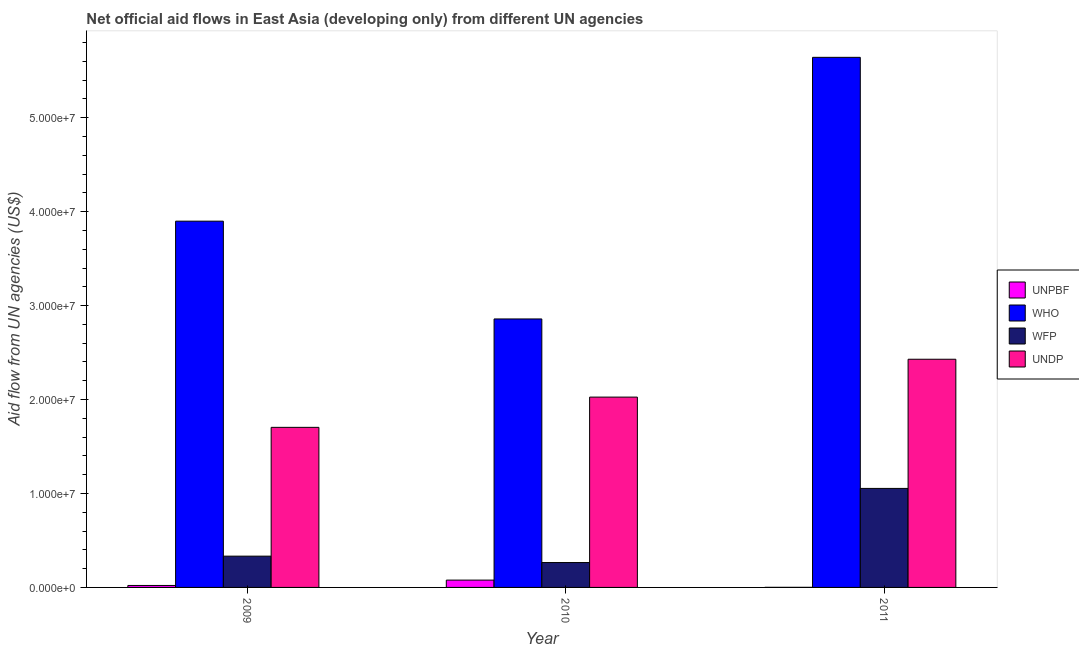Are the number of bars per tick equal to the number of legend labels?
Your answer should be very brief. Yes. Are the number of bars on each tick of the X-axis equal?
Provide a short and direct response. Yes. What is the label of the 1st group of bars from the left?
Ensure brevity in your answer.  2009. What is the amount of aid given by undp in 2011?
Offer a terse response. 2.43e+07. Across all years, what is the maximum amount of aid given by undp?
Give a very brief answer. 2.43e+07. Across all years, what is the minimum amount of aid given by unpbf?
Your answer should be very brief. 10000. What is the total amount of aid given by wfp in the graph?
Offer a very short reply. 1.65e+07. What is the difference between the amount of aid given by unpbf in 2009 and that in 2010?
Your response must be concise. -5.70e+05. What is the difference between the amount of aid given by undp in 2009 and the amount of aid given by unpbf in 2011?
Offer a terse response. -7.25e+06. What is the average amount of aid given by unpbf per year?
Keep it short and to the point. 3.33e+05. In how many years, is the amount of aid given by undp greater than 34000000 US$?
Offer a terse response. 0. What is the ratio of the amount of aid given by who in 2010 to that in 2011?
Give a very brief answer. 0.51. Is the amount of aid given by unpbf in 2010 less than that in 2011?
Your response must be concise. No. Is the difference between the amount of aid given by unpbf in 2009 and 2010 greater than the difference between the amount of aid given by who in 2009 and 2010?
Give a very brief answer. No. What is the difference between the highest and the second highest amount of aid given by undp?
Provide a succinct answer. 4.03e+06. What is the difference between the highest and the lowest amount of aid given by unpbf?
Offer a terse response. 7.70e+05. Is it the case that in every year, the sum of the amount of aid given by wfp and amount of aid given by undp is greater than the sum of amount of aid given by who and amount of aid given by unpbf?
Your response must be concise. Yes. What does the 2nd bar from the left in 2009 represents?
Offer a very short reply. WHO. What does the 3rd bar from the right in 2009 represents?
Offer a terse response. WHO. Is it the case that in every year, the sum of the amount of aid given by unpbf and amount of aid given by who is greater than the amount of aid given by wfp?
Provide a succinct answer. Yes. Are the values on the major ticks of Y-axis written in scientific E-notation?
Make the answer very short. Yes. Does the graph contain grids?
Your answer should be very brief. No. How are the legend labels stacked?
Make the answer very short. Vertical. What is the title of the graph?
Ensure brevity in your answer.  Net official aid flows in East Asia (developing only) from different UN agencies. What is the label or title of the X-axis?
Provide a short and direct response. Year. What is the label or title of the Y-axis?
Your response must be concise. Aid flow from UN agencies (US$). What is the Aid flow from UN agencies (US$) in WHO in 2009?
Your response must be concise. 3.90e+07. What is the Aid flow from UN agencies (US$) in WFP in 2009?
Ensure brevity in your answer.  3.33e+06. What is the Aid flow from UN agencies (US$) of UNDP in 2009?
Keep it short and to the point. 1.70e+07. What is the Aid flow from UN agencies (US$) of UNPBF in 2010?
Provide a succinct answer. 7.80e+05. What is the Aid flow from UN agencies (US$) of WHO in 2010?
Ensure brevity in your answer.  2.86e+07. What is the Aid flow from UN agencies (US$) in WFP in 2010?
Offer a very short reply. 2.65e+06. What is the Aid flow from UN agencies (US$) in UNDP in 2010?
Offer a very short reply. 2.03e+07. What is the Aid flow from UN agencies (US$) of WHO in 2011?
Your answer should be very brief. 5.64e+07. What is the Aid flow from UN agencies (US$) in WFP in 2011?
Your answer should be compact. 1.05e+07. What is the Aid flow from UN agencies (US$) in UNDP in 2011?
Give a very brief answer. 2.43e+07. Across all years, what is the maximum Aid flow from UN agencies (US$) of UNPBF?
Keep it short and to the point. 7.80e+05. Across all years, what is the maximum Aid flow from UN agencies (US$) of WHO?
Offer a terse response. 5.64e+07. Across all years, what is the maximum Aid flow from UN agencies (US$) of WFP?
Offer a very short reply. 1.05e+07. Across all years, what is the maximum Aid flow from UN agencies (US$) in UNDP?
Provide a succinct answer. 2.43e+07. Across all years, what is the minimum Aid flow from UN agencies (US$) of UNPBF?
Give a very brief answer. 10000. Across all years, what is the minimum Aid flow from UN agencies (US$) of WHO?
Your answer should be compact. 2.86e+07. Across all years, what is the minimum Aid flow from UN agencies (US$) of WFP?
Your answer should be very brief. 2.65e+06. Across all years, what is the minimum Aid flow from UN agencies (US$) in UNDP?
Keep it short and to the point. 1.70e+07. What is the total Aid flow from UN agencies (US$) of UNPBF in the graph?
Offer a very short reply. 1.00e+06. What is the total Aid flow from UN agencies (US$) in WHO in the graph?
Your answer should be very brief. 1.24e+08. What is the total Aid flow from UN agencies (US$) in WFP in the graph?
Make the answer very short. 1.65e+07. What is the total Aid flow from UN agencies (US$) in UNDP in the graph?
Offer a very short reply. 6.16e+07. What is the difference between the Aid flow from UN agencies (US$) of UNPBF in 2009 and that in 2010?
Your answer should be compact. -5.70e+05. What is the difference between the Aid flow from UN agencies (US$) in WHO in 2009 and that in 2010?
Your answer should be compact. 1.04e+07. What is the difference between the Aid flow from UN agencies (US$) of WFP in 2009 and that in 2010?
Your answer should be compact. 6.80e+05. What is the difference between the Aid flow from UN agencies (US$) of UNDP in 2009 and that in 2010?
Ensure brevity in your answer.  -3.22e+06. What is the difference between the Aid flow from UN agencies (US$) of WHO in 2009 and that in 2011?
Keep it short and to the point. -1.74e+07. What is the difference between the Aid flow from UN agencies (US$) of WFP in 2009 and that in 2011?
Ensure brevity in your answer.  -7.21e+06. What is the difference between the Aid flow from UN agencies (US$) of UNDP in 2009 and that in 2011?
Provide a succinct answer. -7.25e+06. What is the difference between the Aid flow from UN agencies (US$) in UNPBF in 2010 and that in 2011?
Offer a very short reply. 7.70e+05. What is the difference between the Aid flow from UN agencies (US$) in WHO in 2010 and that in 2011?
Give a very brief answer. -2.78e+07. What is the difference between the Aid flow from UN agencies (US$) of WFP in 2010 and that in 2011?
Provide a short and direct response. -7.89e+06. What is the difference between the Aid flow from UN agencies (US$) in UNDP in 2010 and that in 2011?
Offer a very short reply. -4.03e+06. What is the difference between the Aid flow from UN agencies (US$) of UNPBF in 2009 and the Aid flow from UN agencies (US$) of WHO in 2010?
Keep it short and to the point. -2.84e+07. What is the difference between the Aid flow from UN agencies (US$) in UNPBF in 2009 and the Aid flow from UN agencies (US$) in WFP in 2010?
Provide a succinct answer. -2.44e+06. What is the difference between the Aid flow from UN agencies (US$) in UNPBF in 2009 and the Aid flow from UN agencies (US$) in UNDP in 2010?
Keep it short and to the point. -2.00e+07. What is the difference between the Aid flow from UN agencies (US$) in WHO in 2009 and the Aid flow from UN agencies (US$) in WFP in 2010?
Provide a short and direct response. 3.63e+07. What is the difference between the Aid flow from UN agencies (US$) in WHO in 2009 and the Aid flow from UN agencies (US$) in UNDP in 2010?
Provide a short and direct response. 1.87e+07. What is the difference between the Aid flow from UN agencies (US$) in WFP in 2009 and the Aid flow from UN agencies (US$) in UNDP in 2010?
Offer a very short reply. -1.69e+07. What is the difference between the Aid flow from UN agencies (US$) in UNPBF in 2009 and the Aid flow from UN agencies (US$) in WHO in 2011?
Give a very brief answer. -5.62e+07. What is the difference between the Aid flow from UN agencies (US$) of UNPBF in 2009 and the Aid flow from UN agencies (US$) of WFP in 2011?
Provide a succinct answer. -1.03e+07. What is the difference between the Aid flow from UN agencies (US$) in UNPBF in 2009 and the Aid flow from UN agencies (US$) in UNDP in 2011?
Offer a very short reply. -2.41e+07. What is the difference between the Aid flow from UN agencies (US$) of WHO in 2009 and the Aid flow from UN agencies (US$) of WFP in 2011?
Your response must be concise. 2.84e+07. What is the difference between the Aid flow from UN agencies (US$) in WHO in 2009 and the Aid flow from UN agencies (US$) in UNDP in 2011?
Ensure brevity in your answer.  1.47e+07. What is the difference between the Aid flow from UN agencies (US$) of WFP in 2009 and the Aid flow from UN agencies (US$) of UNDP in 2011?
Make the answer very short. -2.10e+07. What is the difference between the Aid flow from UN agencies (US$) of UNPBF in 2010 and the Aid flow from UN agencies (US$) of WHO in 2011?
Your answer should be compact. -5.56e+07. What is the difference between the Aid flow from UN agencies (US$) of UNPBF in 2010 and the Aid flow from UN agencies (US$) of WFP in 2011?
Offer a terse response. -9.76e+06. What is the difference between the Aid flow from UN agencies (US$) in UNPBF in 2010 and the Aid flow from UN agencies (US$) in UNDP in 2011?
Give a very brief answer. -2.35e+07. What is the difference between the Aid flow from UN agencies (US$) of WHO in 2010 and the Aid flow from UN agencies (US$) of WFP in 2011?
Your response must be concise. 1.80e+07. What is the difference between the Aid flow from UN agencies (US$) in WHO in 2010 and the Aid flow from UN agencies (US$) in UNDP in 2011?
Your response must be concise. 4.29e+06. What is the difference between the Aid flow from UN agencies (US$) in WFP in 2010 and the Aid flow from UN agencies (US$) in UNDP in 2011?
Keep it short and to the point. -2.16e+07. What is the average Aid flow from UN agencies (US$) of UNPBF per year?
Your answer should be compact. 3.33e+05. What is the average Aid flow from UN agencies (US$) of WHO per year?
Provide a short and direct response. 4.13e+07. What is the average Aid flow from UN agencies (US$) in WFP per year?
Your answer should be compact. 5.51e+06. What is the average Aid flow from UN agencies (US$) of UNDP per year?
Offer a terse response. 2.05e+07. In the year 2009, what is the difference between the Aid flow from UN agencies (US$) of UNPBF and Aid flow from UN agencies (US$) of WHO?
Offer a very short reply. -3.88e+07. In the year 2009, what is the difference between the Aid flow from UN agencies (US$) in UNPBF and Aid flow from UN agencies (US$) in WFP?
Provide a short and direct response. -3.12e+06. In the year 2009, what is the difference between the Aid flow from UN agencies (US$) in UNPBF and Aid flow from UN agencies (US$) in UNDP?
Provide a succinct answer. -1.68e+07. In the year 2009, what is the difference between the Aid flow from UN agencies (US$) in WHO and Aid flow from UN agencies (US$) in WFP?
Make the answer very short. 3.57e+07. In the year 2009, what is the difference between the Aid flow from UN agencies (US$) in WHO and Aid flow from UN agencies (US$) in UNDP?
Offer a terse response. 2.20e+07. In the year 2009, what is the difference between the Aid flow from UN agencies (US$) of WFP and Aid flow from UN agencies (US$) of UNDP?
Your response must be concise. -1.37e+07. In the year 2010, what is the difference between the Aid flow from UN agencies (US$) in UNPBF and Aid flow from UN agencies (US$) in WHO?
Give a very brief answer. -2.78e+07. In the year 2010, what is the difference between the Aid flow from UN agencies (US$) of UNPBF and Aid flow from UN agencies (US$) of WFP?
Give a very brief answer. -1.87e+06. In the year 2010, what is the difference between the Aid flow from UN agencies (US$) in UNPBF and Aid flow from UN agencies (US$) in UNDP?
Make the answer very short. -1.95e+07. In the year 2010, what is the difference between the Aid flow from UN agencies (US$) of WHO and Aid flow from UN agencies (US$) of WFP?
Ensure brevity in your answer.  2.59e+07. In the year 2010, what is the difference between the Aid flow from UN agencies (US$) in WHO and Aid flow from UN agencies (US$) in UNDP?
Your response must be concise. 8.32e+06. In the year 2010, what is the difference between the Aid flow from UN agencies (US$) of WFP and Aid flow from UN agencies (US$) of UNDP?
Provide a succinct answer. -1.76e+07. In the year 2011, what is the difference between the Aid flow from UN agencies (US$) of UNPBF and Aid flow from UN agencies (US$) of WHO?
Provide a short and direct response. -5.64e+07. In the year 2011, what is the difference between the Aid flow from UN agencies (US$) of UNPBF and Aid flow from UN agencies (US$) of WFP?
Keep it short and to the point. -1.05e+07. In the year 2011, what is the difference between the Aid flow from UN agencies (US$) of UNPBF and Aid flow from UN agencies (US$) of UNDP?
Offer a very short reply. -2.43e+07. In the year 2011, what is the difference between the Aid flow from UN agencies (US$) in WHO and Aid flow from UN agencies (US$) in WFP?
Make the answer very short. 4.59e+07. In the year 2011, what is the difference between the Aid flow from UN agencies (US$) of WHO and Aid flow from UN agencies (US$) of UNDP?
Keep it short and to the point. 3.21e+07. In the year 2011, what is the difference between the Aid flow from UN agencies (US$) of WFP and Aid flow from UN agencies (US$) of UNDP?
Give a very brief answer. -1.38e+07. What is the ratio of the Aid flow from UN agencies (US$) in UNPBF in 2009 to that in 2010?
Keep it short and to the point. 0.27. What is the ratio of the Aid flow from UN agencies (US$) in WHO in 2009 to that in 2010?
Offer a terse response. 1.36. What is the ratio of the Aid flow from UN agencies (US$) in WFP in 2009 to that in 2010?
Give a very brief answer. 1.26. What is the ratio of the Aid flow from UN agencies (US$) in UNDP in 2009 to that in 2010?
Your answer should be very brief. 0.84. What is the ratio of the Aid flow from UN agencies (US$) in WHO in 2009 to that in 2011?
Keep it short and to the point. 0.69. What is the ratio of the Aid flow from UN agencies (US$) of WFP in 2009 to that in 2011?
Make the answer very short. 0.32. What is the ratio of the Aid flow from UN agencies (US$) in UNDP in 2009 to that in 2011?
Give a very brief answer. 0.7. What is the ratio of the Aid flow from UN agencies (US$) in WHO in 2010 to that in 2011?
Make the answer very short. 0.51. What is the ratio of the Aid flow from UN agencies (US$) in WFP in 2010 to that in 2011?
Provide a succinct answer. 0.25. What is the ratio of the Aid flow from UN agencies (US$) in UNDP in 2010 to that in 2011?
Offer a terse response. 0.83. What is the difference between the highest and the second highest Aid flow from UN agencies (US$) of UNPBF?
Provide a succinct answer. 5.70e+05. What is the difference between the highest and the second highest Aid flow from UN agencies (US$) of WHO?
Your answer should be compact. 1.74e+07. What is the difference between the highest and the second highest Aid flow from UN agencies (US$) in WFP?
Keep it short and to the point. 7.21e+06. What is the difference between the highest and the second highest Aid flow from UN agencies (US$) of UNDP?
Your answer should be very brief. 4.03e+06. What is the difference between the highest and the lowest Aid flow from UN agencies (US$) in UNPBF?
Your answer should be compact. 7.70e+05. What is the difference between the highest and the lowest Aid flow from UN agencies (US$) of WHO?
Ensure brevity in your answer.  2.78e+07. What is the difference between the highest and the lowest Aid flow from UN agencies (US$) in WFP?
Your response must be concise. 7.89e+06. What is the difference between the highest and the lowest Aid flow from UN agencies (US$) of UNDP?
Give a very brief answer. 7.25e+06. 